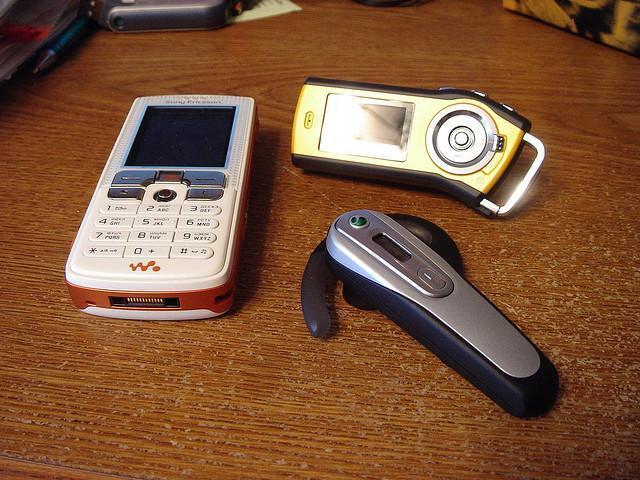How many electronics are in this photo?
Give a very brief answer. 3. How many electronics are displayed?
Give a very brief answer. 3. 